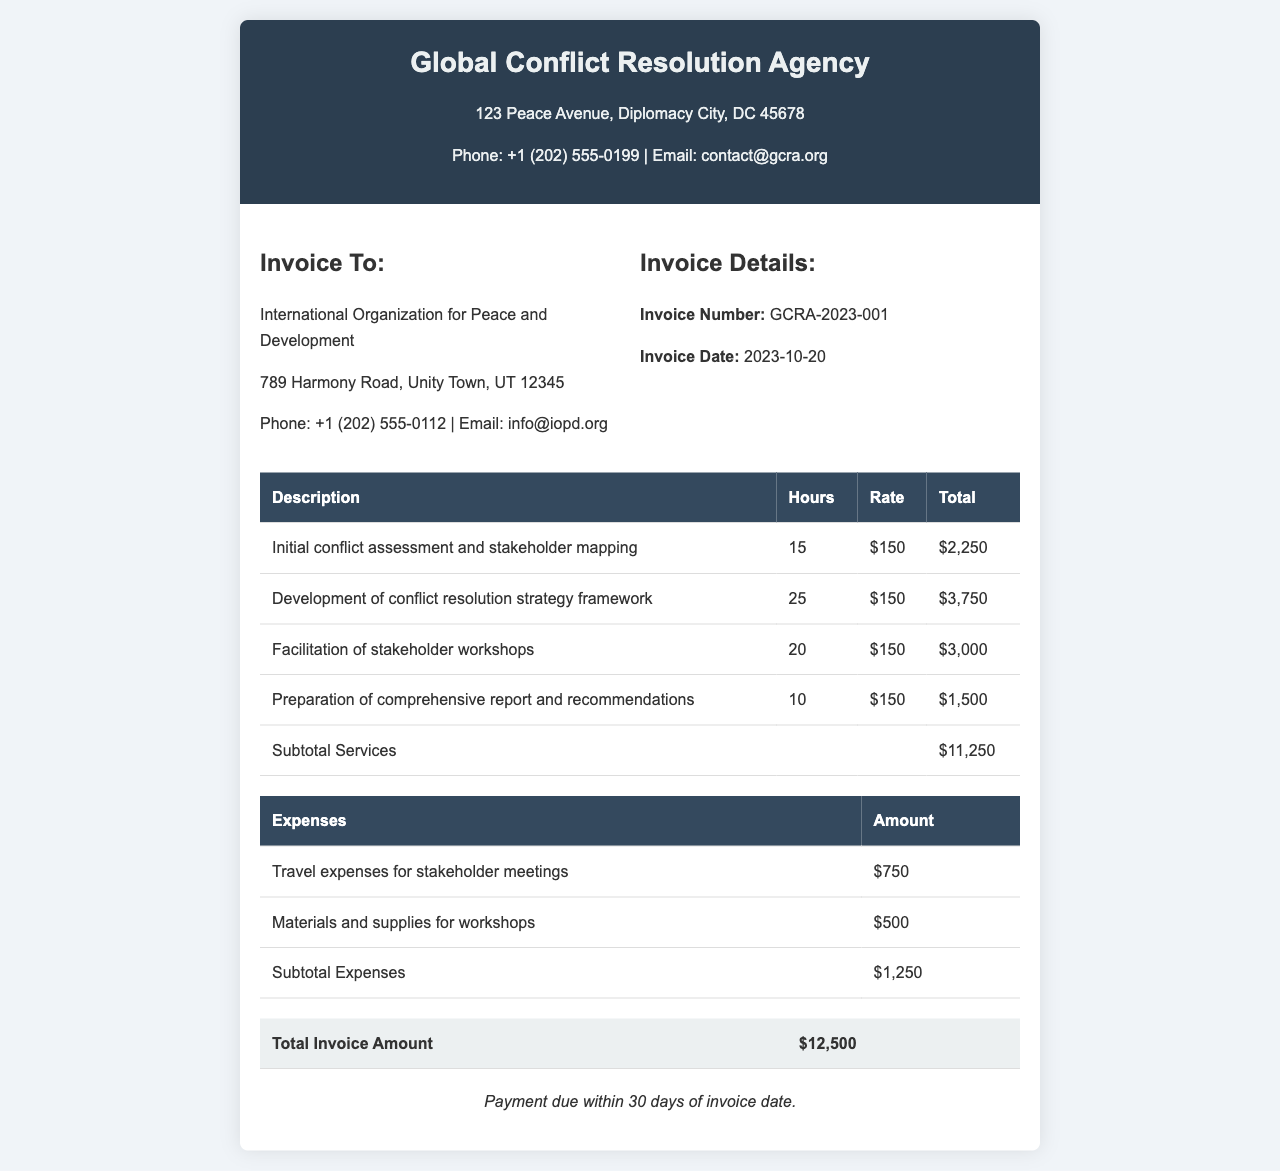What is the invoice number? The invoice number is listed in the invoice details section.
Answer: GCRA-2023-001 What is the total invoice amount? The total amount is indicated at the bottom of the invoice, summarizing all services and expenses.
Answer: $12,500 How many hours were spent on developing the conflict resolution strategy framework? The number of hours for this task is presented in the itemized hours section.
Answer: 25 What is the rate per hour for the consulting services? The rate can be found in each service description and is consistent throughout the invoice.
Answer: $150 What are the total travel expenses for stakeholder meetings? The total for travel expenses is summed up in the expenses table.
Answer: $750 What is the subtotal for services provided? This subtotal is detailed in the summary of the services section.
Answer: $11,250 When is the payment due? Payment terms are stated at the bottom of the invoice.
Answer: 30 days How many stakeholders workshops were facilitated? The number of hours dedicated to this task can indicate the engagement level.
Answer: 20 What is the address of the invoice issuer? The address is provided in the header of the invoice.
Answer: 123 Peace Avenue, Diplomacy City, DC 45678 